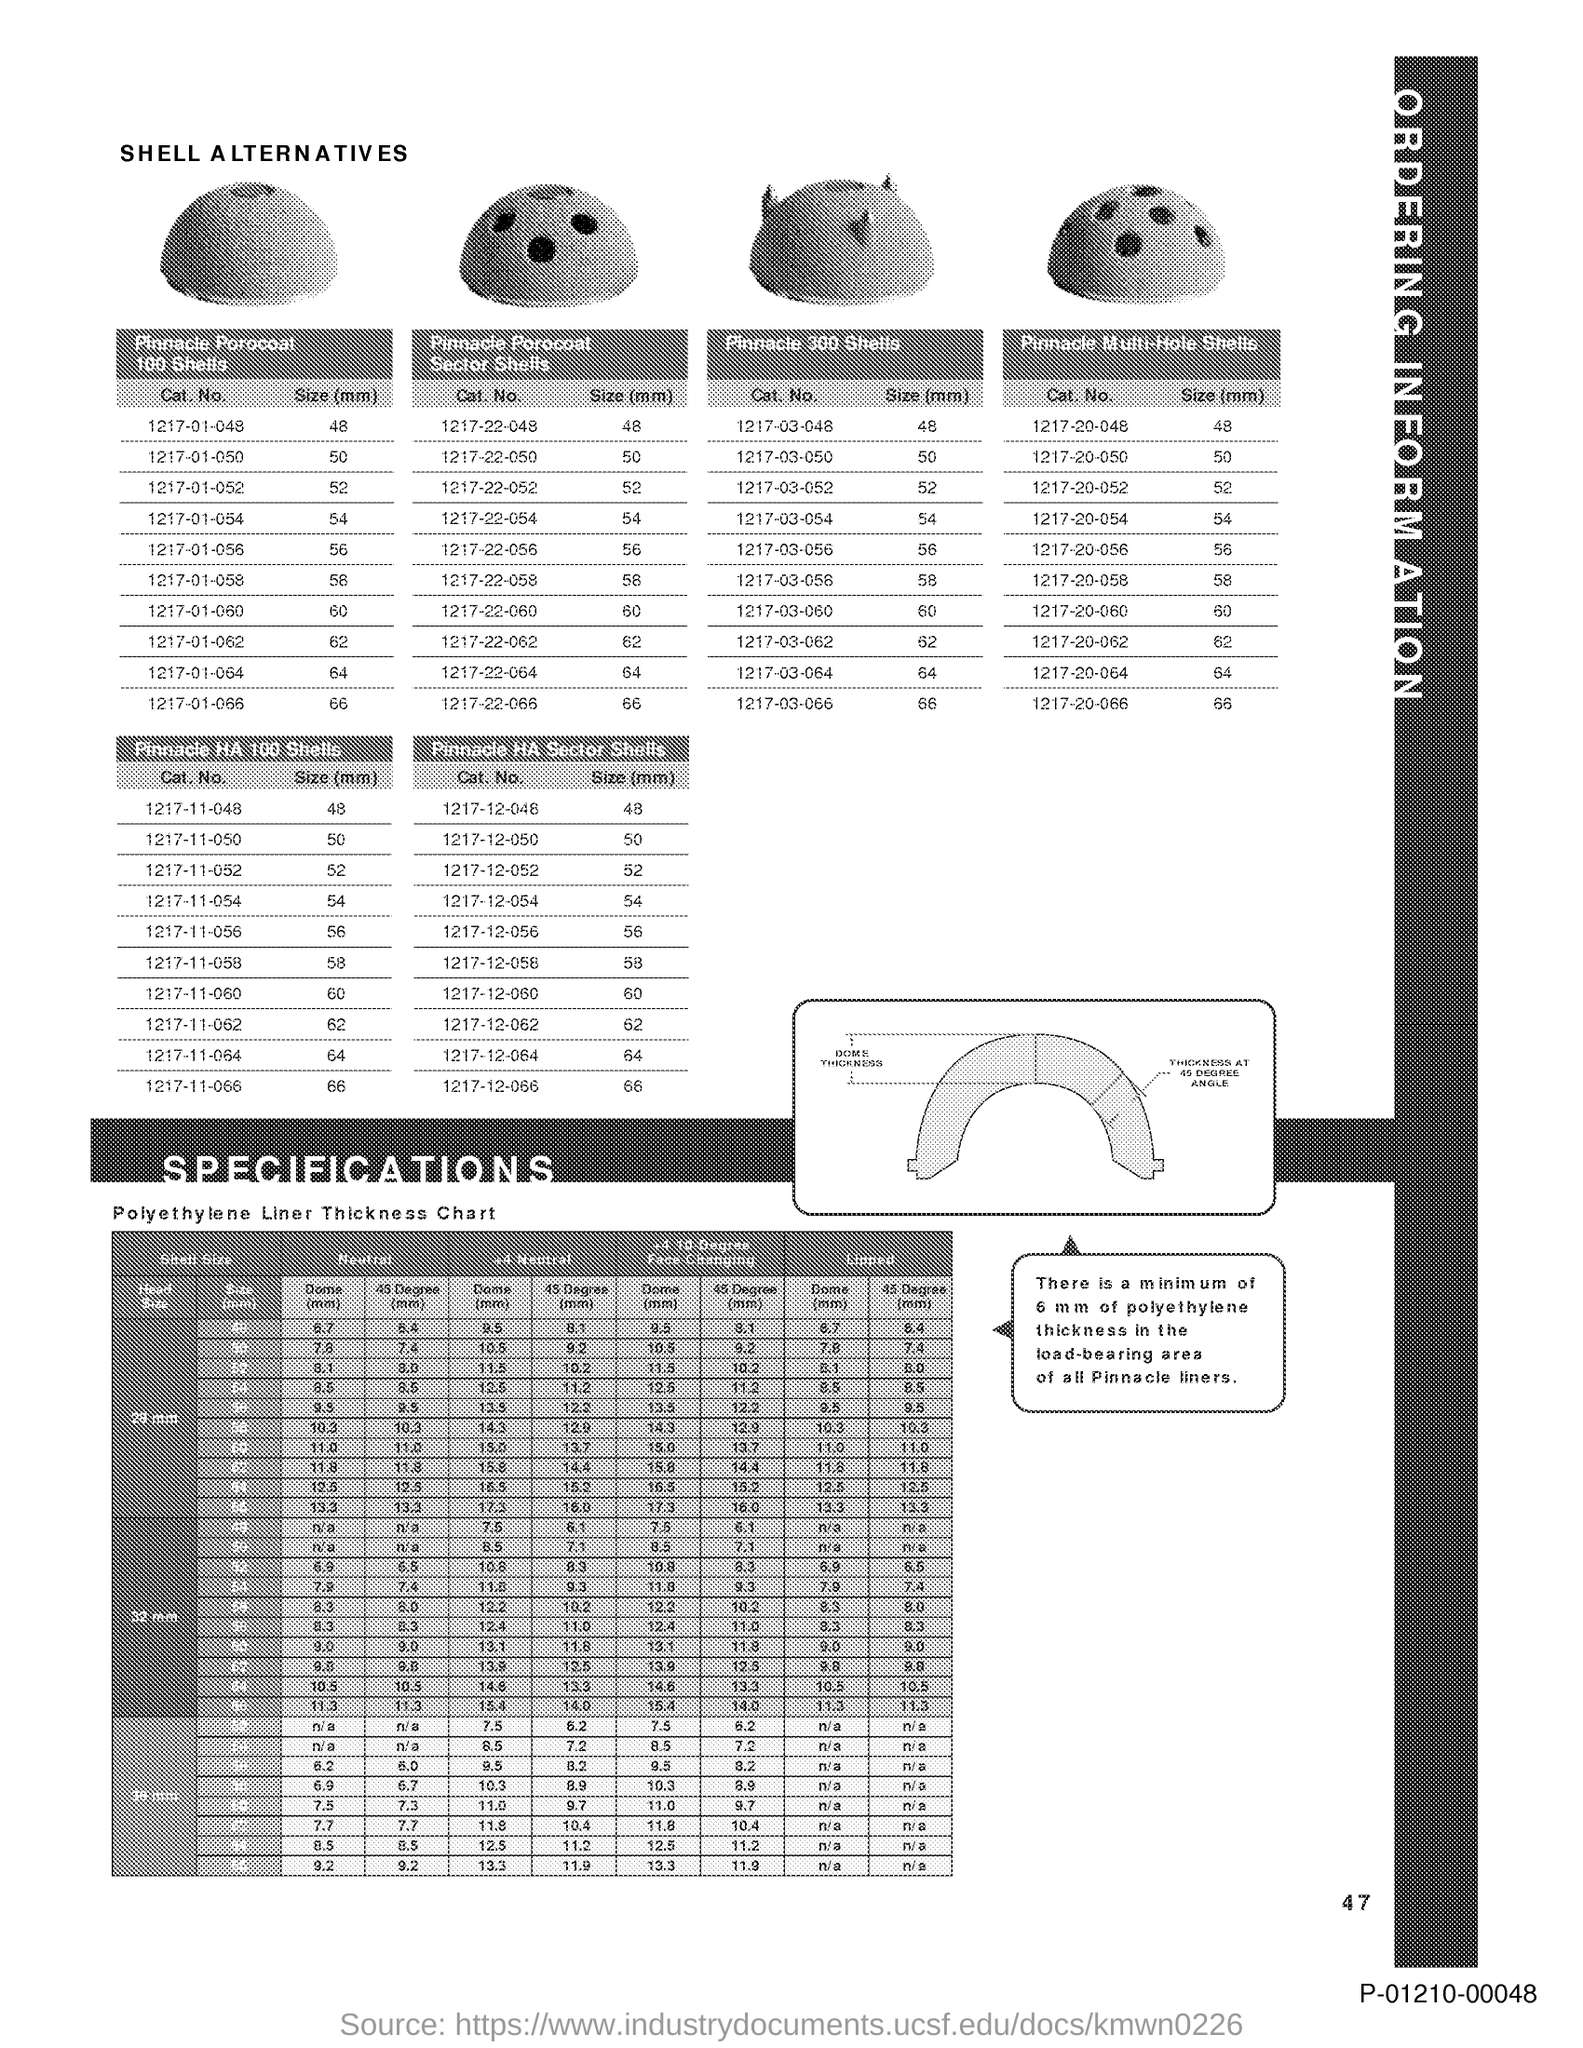What is the Page Number?
Your answer should be compact. 47. 